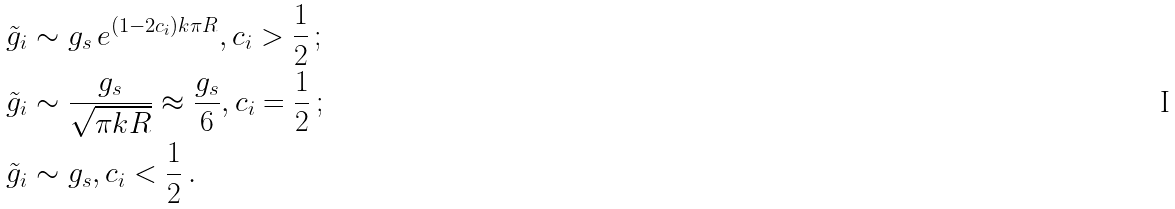Convert formula to latex. <formula><loc_0><loc_0><loc_500><loc_500>\tilde { g } _ { i } & \sim g _ { s } \, e ^ { ( 1 - 2 c _ { i } ) k \pi R } , c _ { i } > \frac { 1 } { 2 } \, ; \\ \tilde { g } _ { i } & \sim \frac { g _ { s } } { \sqrt { \pi k R } } \approx \frac { g _ { s } } { 6 } , c _ { i } = \frac { 1 } { 2 } \, ; \\ \tilde { g } _ { i } & \sim g _ { s } , c _ { i } < \frac { 1 } { 2 } \, .</formula> 